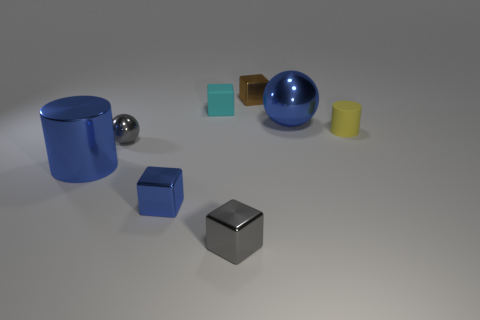Add 1 large green metallic objects. How many objects exist? 9 Subtract all spheres. How many objects are left? 6 Subtract 0 red cylinders. How many objects are left? 8 Subtract all tiny brown shiny cubes. Subtract all spheres. How many objects are left? 5 Add 1 tiny brown metallic cubes. How many tiny brown metallic cubes are left? 2 Add 4 tiny gray spheres. How many tiny gray spheres exist? 5 